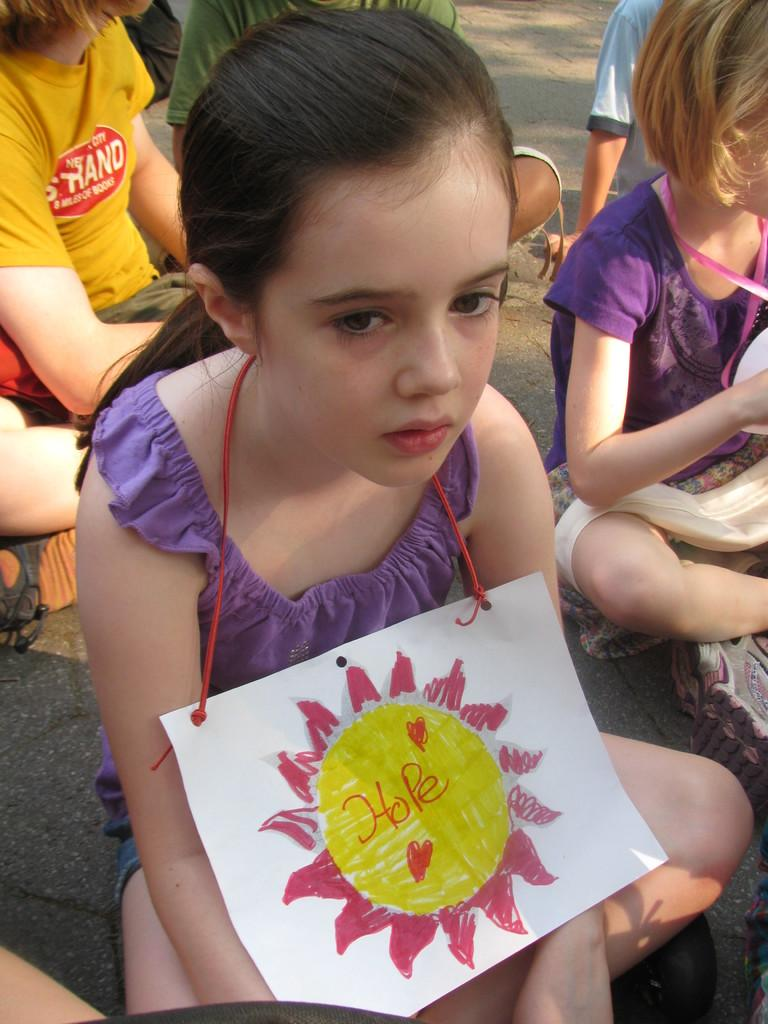What is the main subject of the image? The main subject of the image is a group of kids. Where are the kids located in the image? The kids are sitting on the road in the image. Can you describe any specific details about the kids? Yes, there are two tags around the necks of two kids. What type of clouds can be seen in the image? There are no clouds visible in the image, as it features a group of kids sitting on the road. How do the kids react to the bait in the image? There is no bait present in the image, so it is not possible to determine how the kids might react to it. 